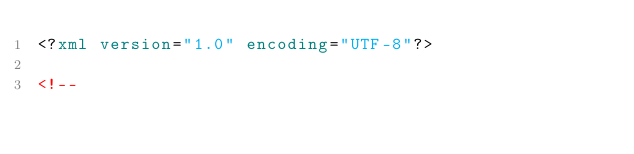Convert code to text. <code><loc_0><loc_0><loc_500><loc_500><_XML_><?xml version="1.0" encoding="UTF-8"?>

<!--</code> 